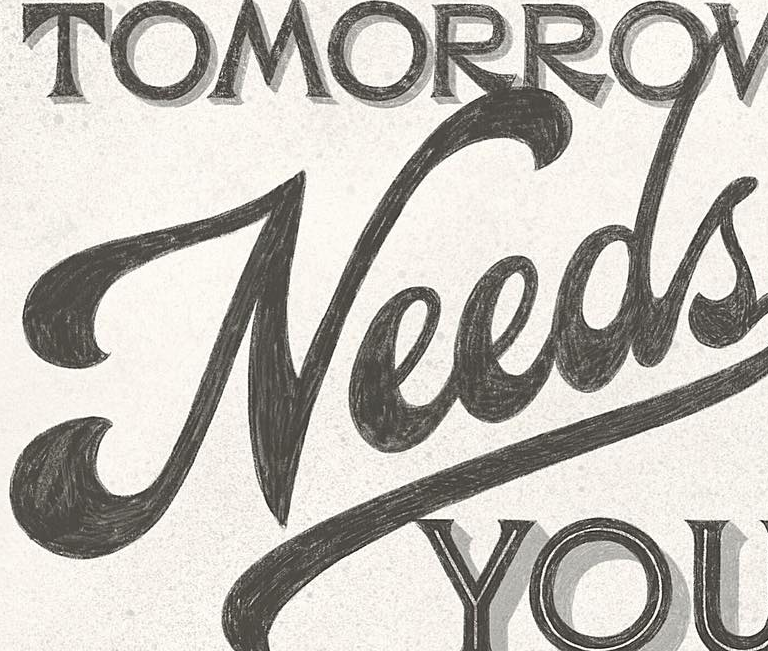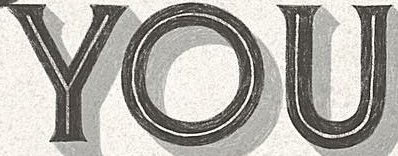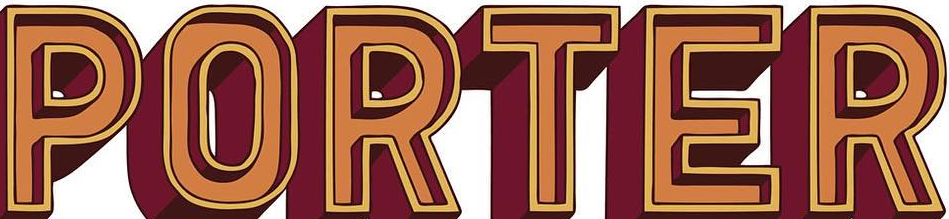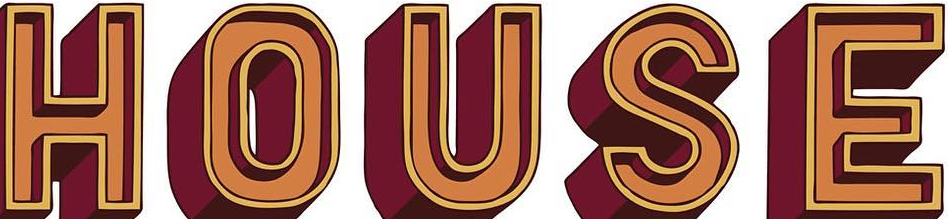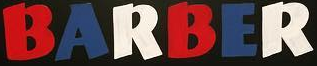Identify the words shown in these images in order, separated by a semicolon. Needs; YOU; PORTER; HOUSE; BARBER 